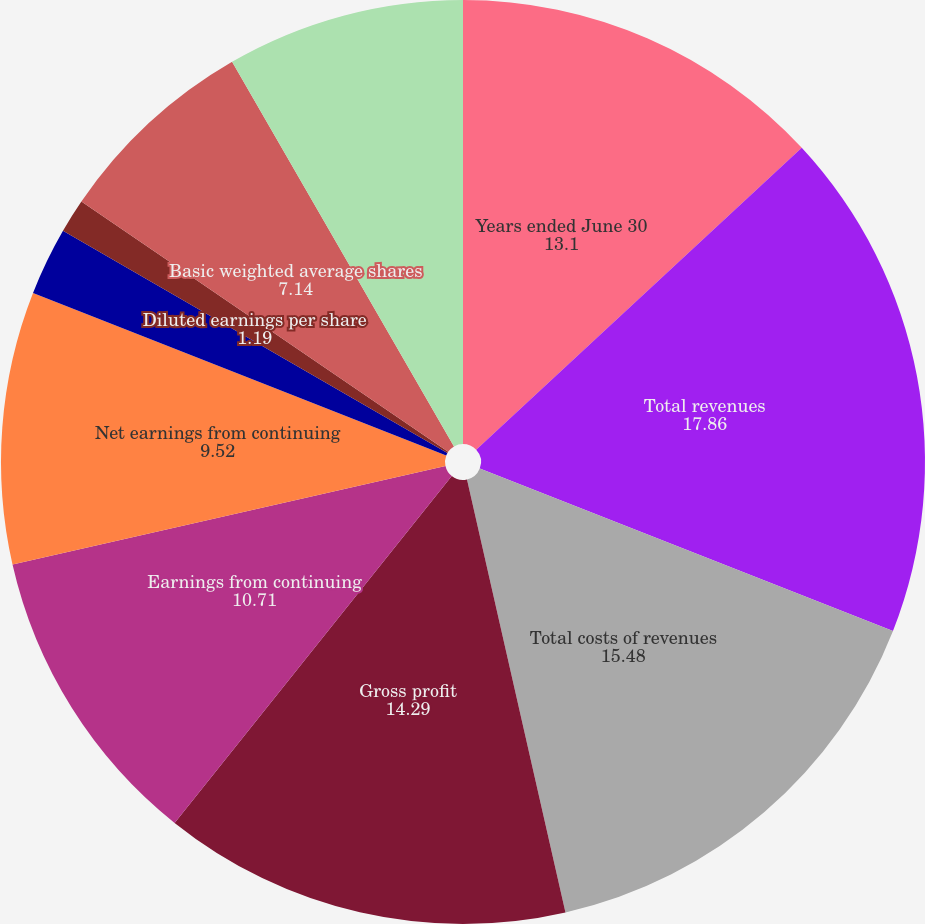Convert chart to OTSL. <chart><loc_0><loc_0><loc_500><loc_500><pie_chart><fcel>Years ended June 30<fcel>Total revenues<fcel>Total costs of revenues<fcel>Gross profit<fcel>Earnings from continuing<fcel>Net earnings from continuing<fcel>Basic earnings per share from<fcel>Diluted earnings per share<fcel>Basic weighted average shares<fcel>Diluted weighted average<nl><fcel>13.1%<fcel>17.86%<fcel>15.48%<fcel>14.29%<fcel>10.71%<fcel>9.52%<fcel>2.38%<fcel>1.19%<fcel>7.14%<fcel>8.33%<nl></chart> 